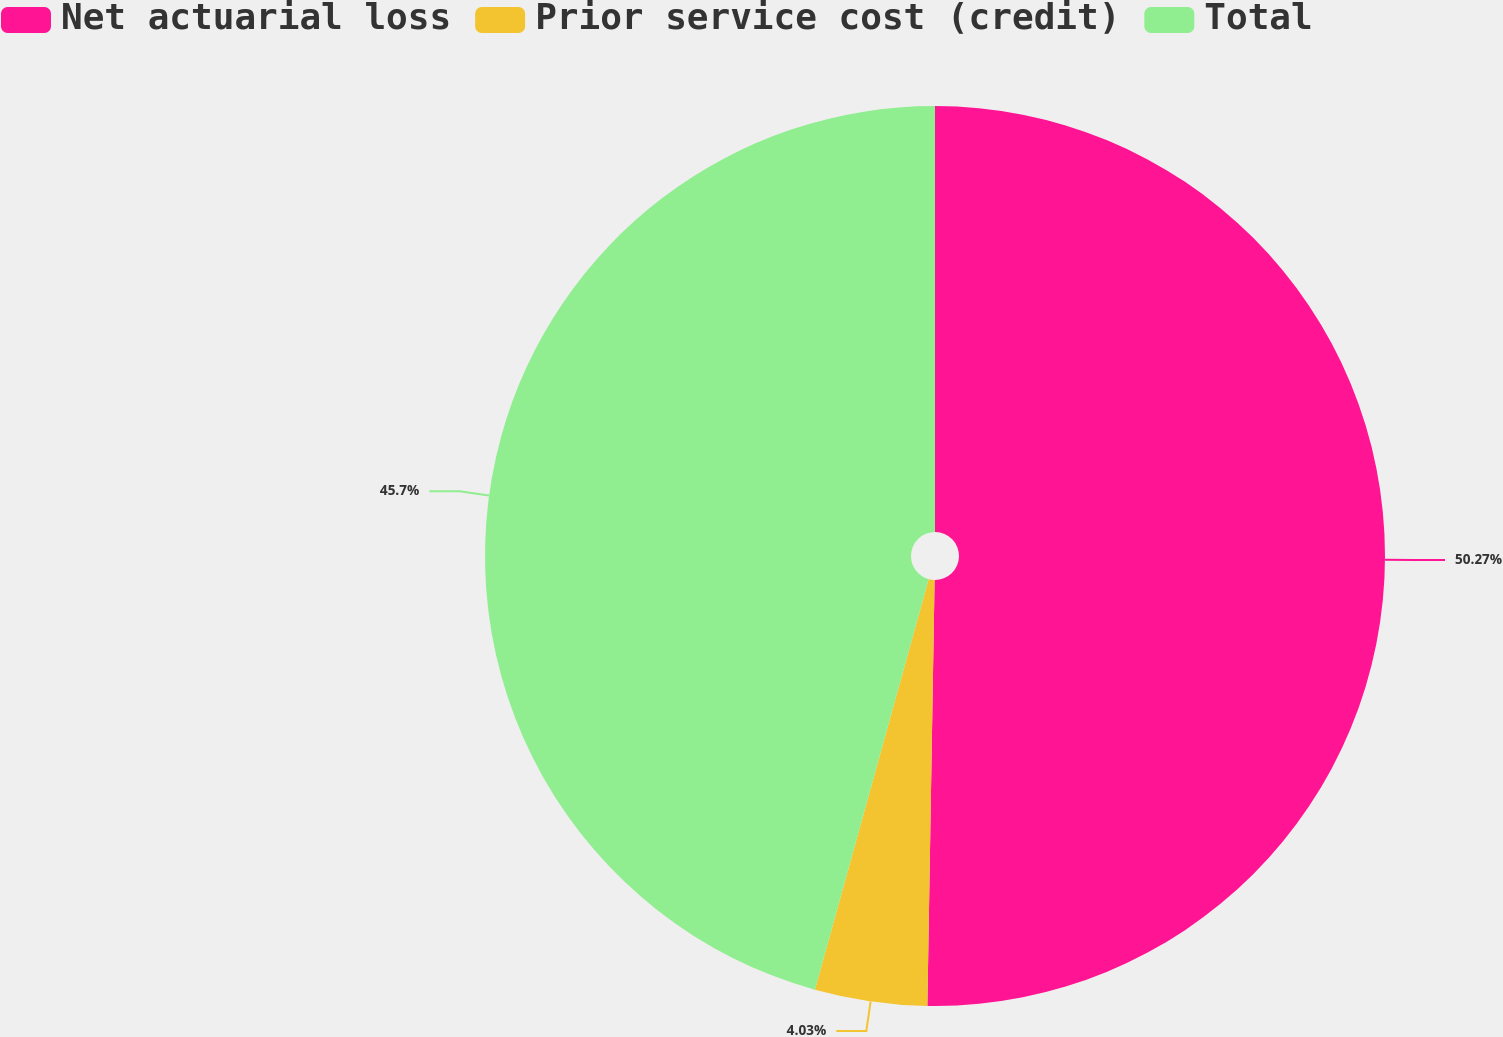Convert chart to OTSL. <chart><loc_0><loc_0><loc_500><loc_500><pie_chart><fcel>Net actuarial loss<fcel>Prior service cost (credit)<fcel>Total<nl><fcel>50.27%<fcel>4.03%<fcel>45.7%<nl></chart> 